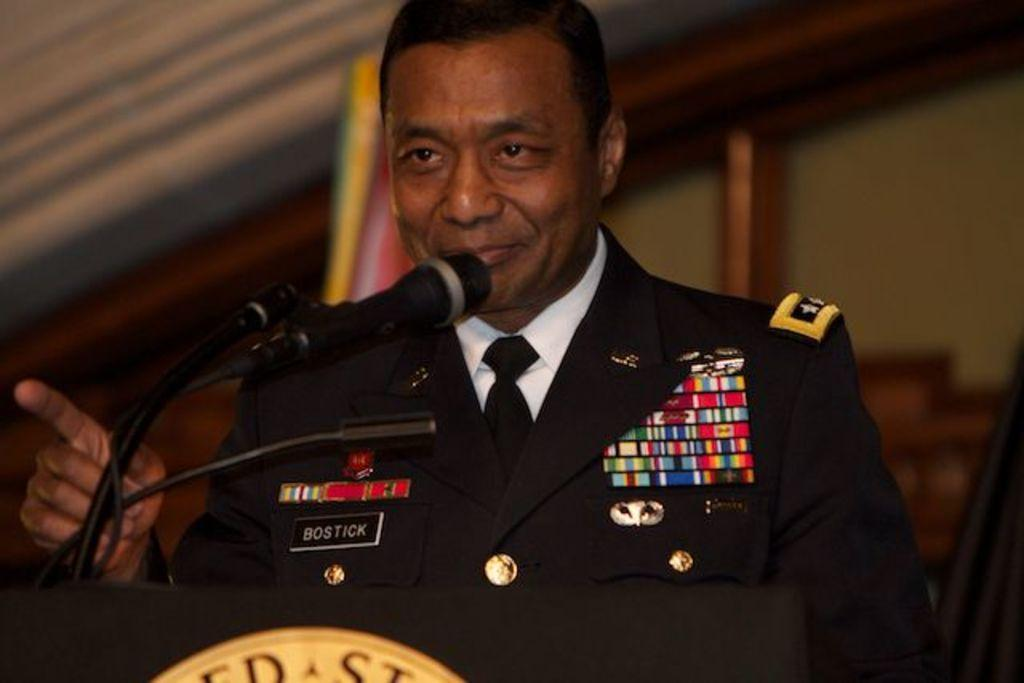Who or what is the main subject in the image? There is a person in the image. What is the person wearing? The person is wearing a black suit. What is the person standing in front of? The person is standing in front of a podium. What is the person likely to use in the image? The person is likely to use the microphone (mike) in front of them. What type of pollution can be seen in the image? There is no pollution visible in the image. Is there a goat present in the image? No, there is no goat present in the image. 